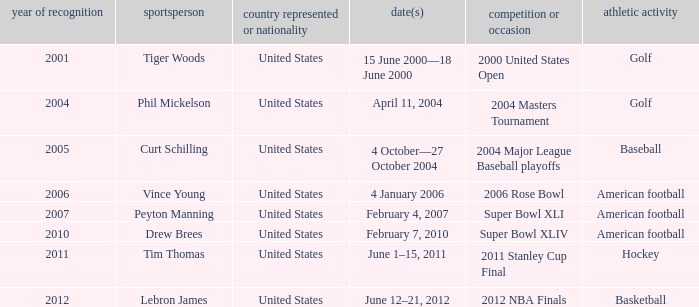In 2011 which sport had the year award? Hockey. 